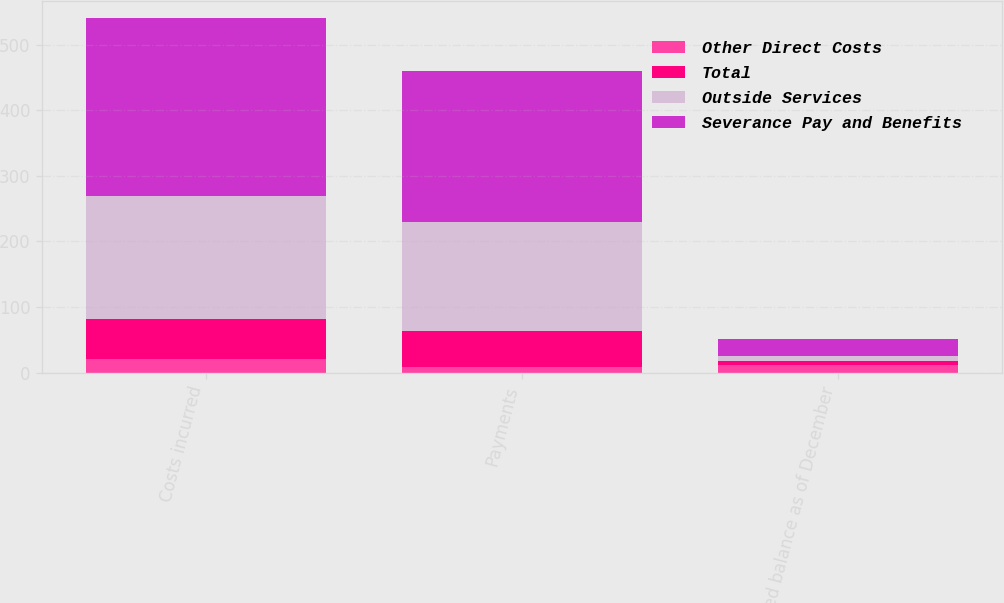<chart> <loc_0><loc_0><loc_500><loc_500><stacked_bar_chart><ecel><fcel>Costs incurred<fcel>Payments<fcel>Accrued balance as of December<nl><fcel>Other Direct Costs<fcel>21<fcel>8<fcel>12<nl><fcel>Total<fcel>61<fcel>55<fcel>6<nl><fcel>Outside Services<fcel>188<fcel>167<fcel>8<nl><fcel>Severance Pay and Benefits<fcel>270<fcel>230<fcel>26<nl></chart> 